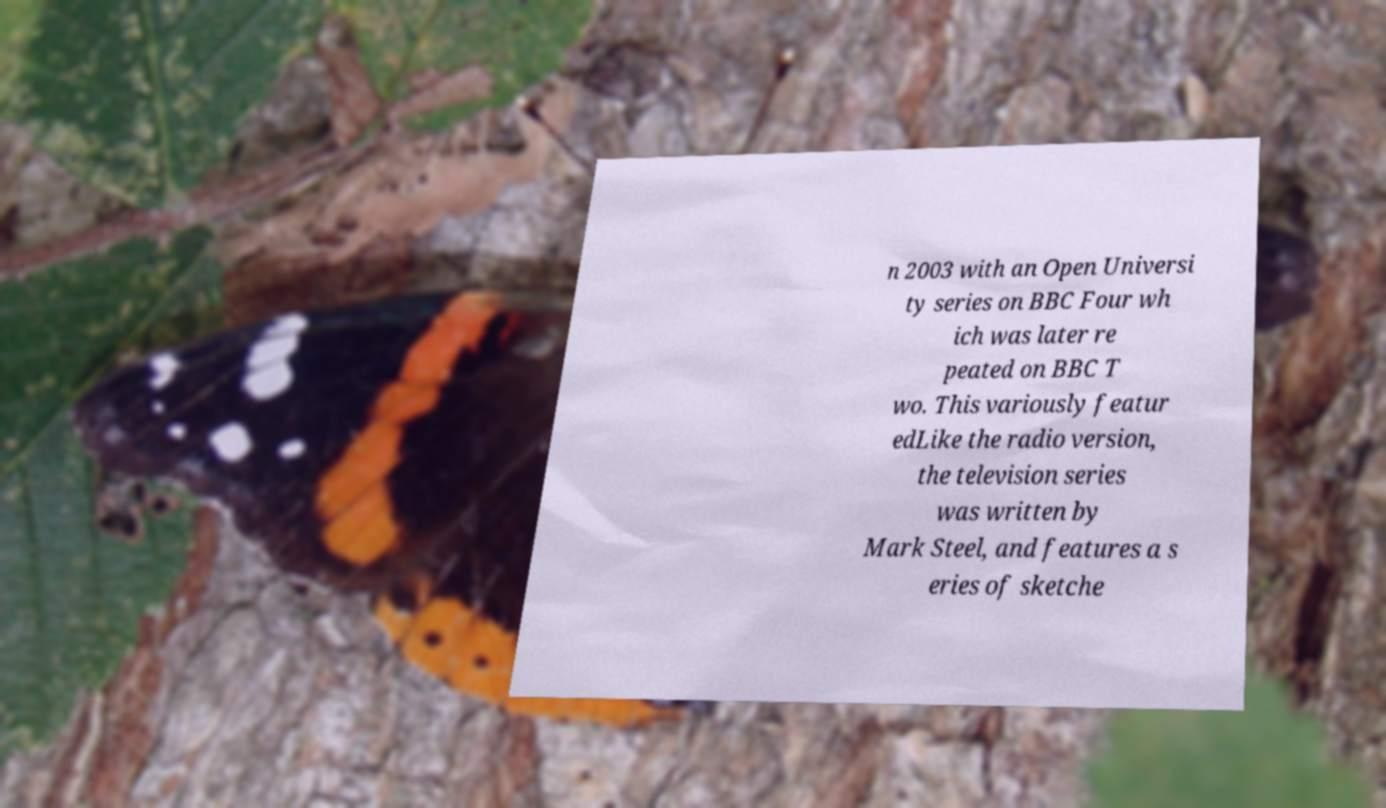Please identify and transcribe the text found in this image. n 2003 with an Open Universi ty series on BBC Four wh ich was later re peated on BBC T wo. This variously featur edLike the radio version, the television series was written by Mark Steel, and features a s eries of sketche 